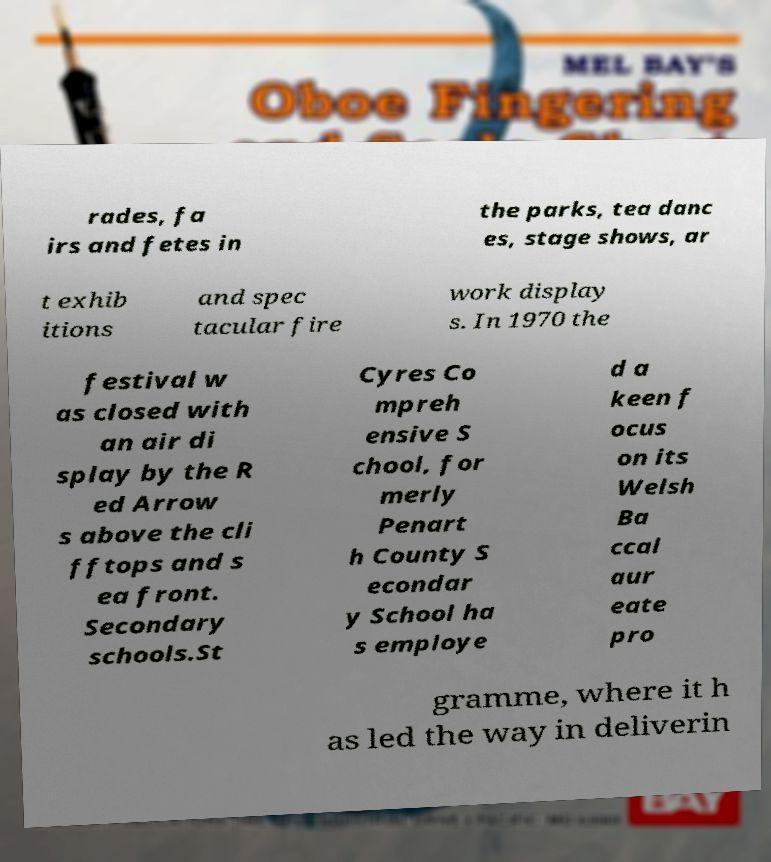There's text embedded in this image that I need extracted. Can you transcribe it verbatim? rades, fa irs and fetes in the parks, tea danc es, stage shows, ar t exhib itions and spec tacular fire work display s. In 1970 the festival w as closed with an air di splay by the R ed Arrow s above the cli fftops and s ea front. Secondary schools.St Cyres Co mpreh ensive S chool, for merly Penart h County S econdar y School ha s employe d a keen f ocus on its Welsh Ba ccal aur eate pro gramme, where it h as led the way in deliverin 